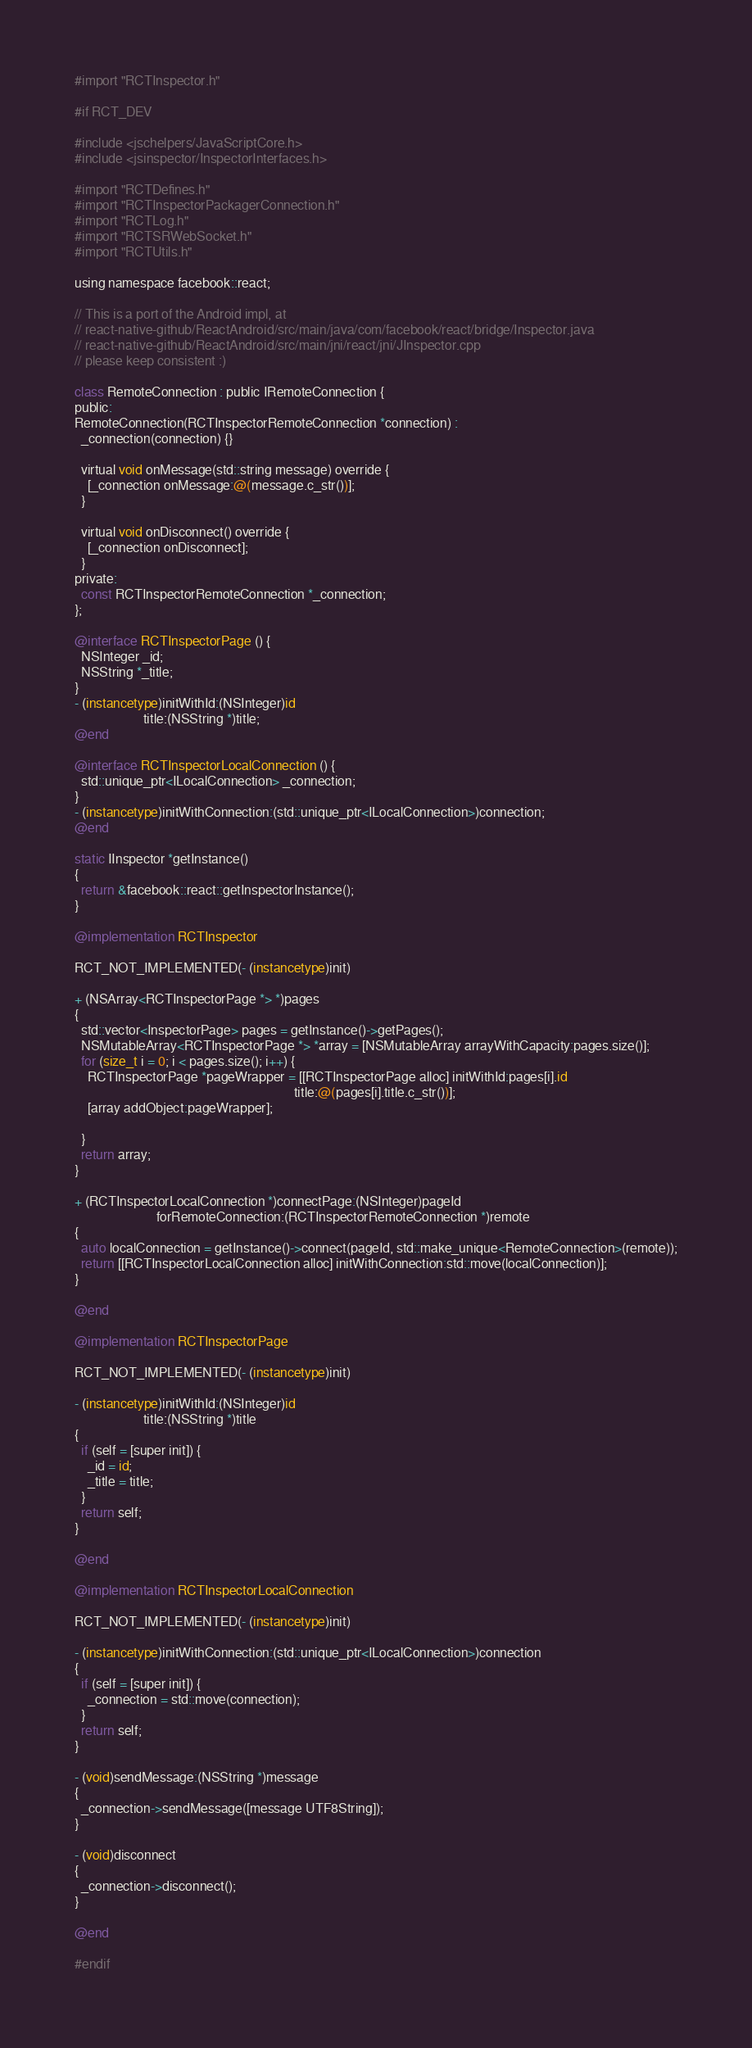Convert code to text. <code><loc_0><loc_0><loc_500><loc_500><_ObjectiveC_>
#import "RCTInspector.h"

#if RCT_DEV

#include <jschelpers/JavaScriptCore.h>
#include <jsinspector/InspectorInterfaces.h>

#import "RCTDefines.h"
#import "RCTInspectorPackagerConnection.h"
#import "RCTLog.h"
#import "RCTSRWebSocket.h"
#import "RCTUtils.h"

using namespace facebook::react;

// This is a port of the Android impl, at
// react-native-github/ReactAndroid/src/main/java/com/facebook/react/bridge/Inspector.java
// react-native-github/ReactAndroid/src/main/jni/react/jni/JInspector.cpp
// please keep consistent :)

class RemoteConnection : public IRemoteConnection {
public:
RemoteConnection(RCTInspectorRemoteConnection *connection) :
  _connection(connection) {}

  virtual void onMessage(std::string message) override {
    [_connection onMessage:@(message.c_str())];
  }

  virtual void onDisconnect() override {
    [_connection onDisconnect];
  }
private:
  const RCTInspectorRemoteConnection *_connection;
};

@interface RCTInspectorPage () {
  NSInteger _id;
  NSString *_title;
}
- (instancetype)initWithId:(NSInteger)id
                     title:(NSString *)title;
@end

@interface RCTInspectorLocalConnection () {
  std::unique_ptr<ILocalConnection> _connection;
}
- (instancetype)initWithConnection:(std::unique_ptr<ILocalConnection>)connection;
@end

static IInspector *getInstance()
{
  return &facebook::react::getInspectorInstance();
}

@implementation RCTInspector

RCT_NOT_IMPLEMENTED(- (instancetype)init)

+ (NSArray<RCTInspectorPage *> *)pages
{
  std::vector<InspectorPage> pages = getInstance()->getPages();
  NSMutableArray<RCTInspectorPage *> *array = [NSMutableArray arrayWithCapacity:pages.size()];
  for (size_t i = 0; i < pages.size(); i++) {
    RCTInspectorPage *pageWrapper = [[RCTInspectorPage alloc] initWithId:pages[i].id
                                                                   title:@(pages[i].title.c_str())];
    [array addObject:pageWrapper];

  }
  return array;
}

+ (RCTInspectorLocalConnection *)connectPage:(NSInteger)pageId
                         forRemoteConnection:(RCTInspectorRemoteConnection *)remote
{
  auto localConnection = getInstance()->connect(pageId, std::make_unique<RemoteConnection>(remote));
  return [[RCTInspectorLocalConnection alloc] initWithConnection:std::move(localConnection)];
}

@end

@implementation RCTInspectorPage

RCT_NOT_IMPLEMENTED(- (instancetype)init)

- (instancetype)initWithId:(NSInteger)id
                     title:(NSString *)title
{
  if (self = [super init]) {
    _id = id;
    _title = title;
  }
  return self;
}

@end

@implementation RCTInspectorLocalConnection

RCT_NOT_IMPLEMENTED(- (instancetype)init)

- (instancetype)initWithConnection:(std::unique_ptr<ILocalConnection>)connection
{
  if (self = [super init]) {
    _connection = std::move(connection);
  }
  return self;
}

- (void)sendMessage:(NSString *)message
{
  _connection->sendMessage([message UTF8String]);
}

- (void)disconnect
{
  _connection->disconnect();
}

@end

#endif
</code> 